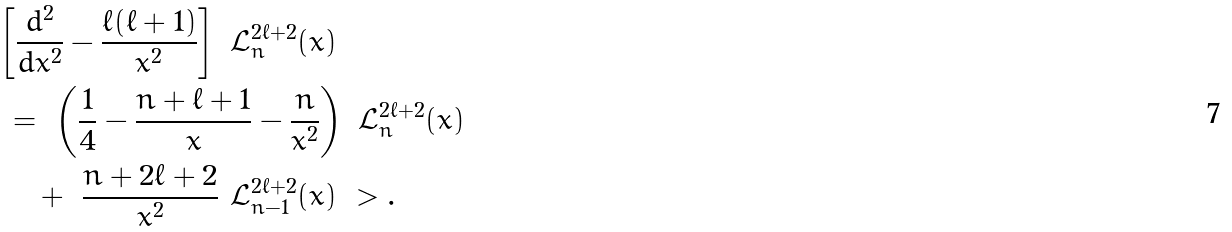Convert formula to latex. <formula><loc_0><loc_0><loc_500><loc_500>& \left [ \frac { d ^ { 2 } } { d x ^ { 2 } } - \frac { \ell ( \ell + 1 ) } { x ^ { 2 } } \right ] \ \mathcal { L } _ { n } ^ { 2 \ell + 2 } ( x ) \\ & \ = \ \left ( \frac { 1 } { 4 } - \frac { n + \ell + 1 } { x } - \frac { n } { x ^ { 2 } } \right ) \ \mathcal { L } _ { n } ^ { 2 \ell + 2 } ( x ) \\ \quad & \quad \ + \ \frac { n + 2 \ell + 2 } { x ^ { 2 } } \ \mathcal { L } _ { n - 1 } ^ { 2 \ell + 2 } ( x ) \ > .</formula> 